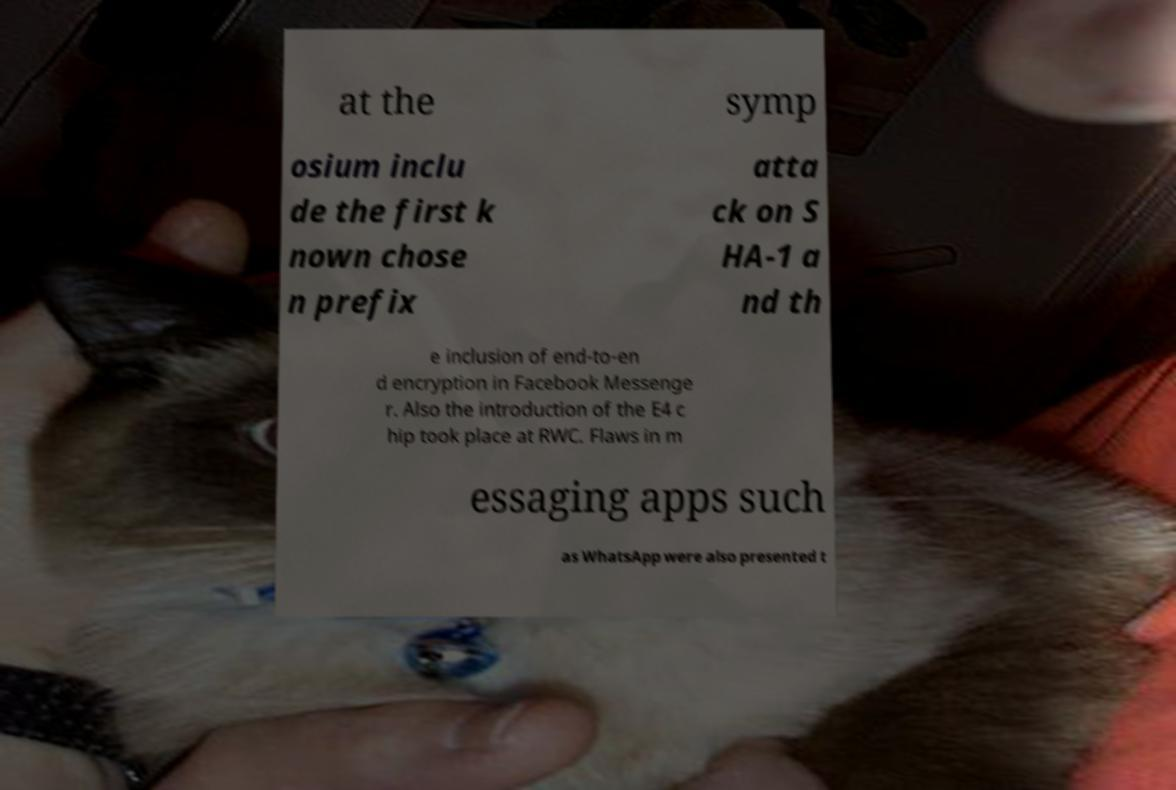Could you extract and type out the text from this image? at the symp osium inclu de the first k nown chose n prefix atta ck on S HA-1 a nd th e inclusion of end-to-en d encryption in Facebook Messenge r. Also the introduction of the E4 c hip took place at RWC. Flaws in m essaging apps such as WhatsApp were also presented t 